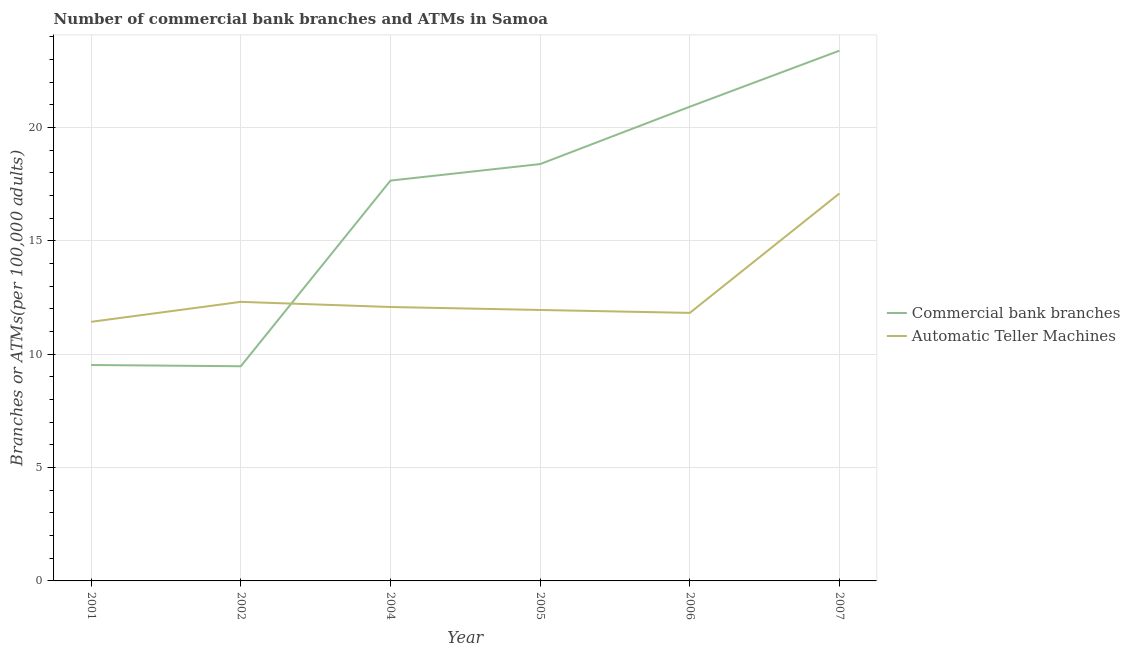How many different coloured lines are there?
Your answer should be very brief. 2. Does the line corresponding to number of atms intersect with the line corresponding to number of commercal bank branches?
Your answer should be compact. Yes. What is the number of atms in 2001?
Give a very brief answer. 11.43. Across all years, what is the maximum number of commercal bank branches?
Provide a succinct answer. 23.4. Across all years, what is the minimum number of commercal bank branches?
Offer a terse response. 9.47. In which year was the number of commercal bank branches maximum?
Ensure brevity in your answer.  2007. What is the total number of atms in the graph?
Make the answer very short. 76.71. What is the difference between the number of atms in 2001 and that in 2004?
Provide a short and direct response. -0.65. What is the difference between the number of atms in 2006 and the number of commercal bank branches in 2001?
Your answer should be very brief. 2.3. What is the average number of atms per year?
Ensure brevity in your answer.  12.79. In the year 2001, what is the difference between the number of commercal bank branches and number of atms?
Your response must be concise. -1.91. In how many years, is the number of commercal bank branches greater than 8?
Your answer should be compact. 6. What is the ratio of the number of atms in 2005 to that in 2006?
Ensure brevity in your answer.  1.01. Is the difference between the number of atms in 2002 and 2005 greater than the difference between the number of commercal bank branches in 2002 and 2005?
Offer a terse response. Yes. What is the difference between the highest and the second highest number of atms?
Provide a succinct answer. 4.78. What is the difference between the highest and the lowest number of atms?
Your answer should be compact. 5.67. In how many years, is the number of commercal bank branches greater than the average number of commercal bank branches taken over all years?
Your answer should be compact. 4. Where does the legend appear in the graph?
Offer a very short reply. Center right. What is the title of the graph?
Ensure brevity in your answer.  Number of commercial bank branches and ATMs in Samoa. What is the label or title of the Y-axis?
Your answer should be compact. Branches or ATMs(per 100,0 adults). What is the Branches or ATMs(per 100,000 adults) of Commercial bank branches in 2001?
Provide a short and direct response. 9.53. What is the Branches or ATMs(per 100,000 adults) of Automatic Teller Machines in 2001?
Offer a terse response. 11.43. What is the Branches or ATMs(per 100,000 adults) of Commercial bank branches in 2002?
Keep it short and to the point. 9.47. What is the Branches or ATMs(per 100,000 adults) of Automatic Teller Machines in 2002?
Your answer should be very brief. 12.31. What is the Branches or ATMs(per 100,000 adults) in Commercial bank branches in 2004?
Offer a terse response. 17.66. What is the Branches or ATMs(per 100,000 adults) of Automatic Teller Machines in 2004?
Provide a short and direct response. 12.09. What is the Branches or ATMs(per 100,000 adults) of Commercial bank branches in 2005?
Provide a short and direct response. 18.39. What is the Branches or ATMs(per 100,000 adults) in Automatic Teller Machines in 2005?
Your answer should be compact. 11.96. What is the Branches or ATMs(per 100,000 adults) of Commercial bank branches in 2006?
Provide a succinct answer. 20.92. What is the Branches or ATMs(per 100,000 adults) of Automatic Teller Machines in 2006?
Make the answer very short. 11.83. What is the Branches or ATMs(per 100,000 adults) in Commercial bank branches in 2007?
Keep it short and to the point. 23.4. What is the Branches or ATMs(per 100,000 adults) in Automatic Teller Machines in 2007?
Ensure brevity in your answer.  17.1. Across all years, what is the maximum Branches or ATMs(per 100,000 adults) in Commercial bank branches?
Keep it short and to the point. 23.4. Across all years, what is the maximum Branches or ATMs(per 100,000 adults) in Automatic Teller Machines?
Your response must be concise. 17.1. Across all years, what is the minimum Branches or ATMs(per 100,000 adults) of Commercial bank branches?
Ensure brevity in your answer.  9.47. Across all years, what is the minimum Branches or ATMs(per 100,000 adults) in Automatic Teller Machines?
Offer a very short reply. 11.43. What is the total Branches or ATMs(per 100,000 adults) in Commercial bank branches in the graph?
Provide a succinct answer. 99.38. What is the total Branches or ATMs(per 100,000 adults) in Automatic Teller Machines in the graph?
Offer a terse response. 76.71. What is the difference between the Branches or ATMs(per 100,000 adults) of Commercial bank branches in 2001 and that in 2002?
Give a very brief answer. 0.06. What is the difference between the Branches or ATMs(per 100,000 adults) of Automatic Teller Machines in 2001 and that in 2002?
Provide a succinct answer. -0.88. What is the difference between the Branches or ATMs(per 100,000 adults) in Commercial bank branches in 2001 and that in 2004?
Keep it short and to the point. -8.14. What is the difference between the Branches or ATMs(per 100,000 adults) of Automatic Teller Machines in 2001 and that in 2004?
Ensure brevity in your answer.  -0.65. What is the difference between the Branches or ATMs(per 100,000 adults) of Commercial bank branches in 2001 and that in 2005?
Keep it short and to the point. -8.87. What is the difference between the Branches or ATMs(per 100,000 adults) of Automatic Teller Machines in 2001 and that in 2005?
Your response must be concise. -0.52. What is the difference between the Branches or ATMs(per 100,000 adults) of Commercial bank branches in 2001 and that in 2006?
Offer a very short reply. -11.4. What is the difference between the Branches or ATMs(per 100,000 adults) of Automatic Teller Machines in 2001 and that in 2006?
Your answer should be very brief. -0.39. What is the difference between the Branches or ATMs(per 100,000 adults) of Commercial bank branches in 2001 and that in 2007?
Provide a short and direct response. -13.87. What is the difference between the Branches or ATMs(per 100,000 adults) in Automatic Teller Machines in 2001 and that in 2007?
Give a very brief answer. -5.67. What is the difference between the Branches or ATMs(per 100,000 adults) of Commercial bank branches in 2002 and that in 2004?
Your answer should be compact. -8.19. What is the difference between the Branches or ATMs(per 100,000 adults) of Automatic Teller Machines in 2002 and that in 2004?
Ensure brevity in your answer.  0.23. What is the difference between the Branches or ATMs(per 100,000 adults) in Commercial bank branches in 2002 and that in 2005?
Your answer should be very brief. -8.92. What is the difference between the Branches or ATMs(per 100,000 adults) in Automatic Teller Machines in 2002 and that in 2005?
Offer a terse response. 0.36. What is the difference between the Branches or ATMs(per 100,000 adults) in Commercial bank branches in 2002 and that in 2006?
Your answer should be very brief. -11.45. What is the difference between the Branches or ATMs(per 100,000 adults) in Automatic Teller Machines in 2002 and that in 2006?
Give a very brief answer. 0.49. What is the difference between the Branches or ATMs(per 100,000 adults) in Commercial bank branches in 2002 and that in 2007?
Your response must be concise. -13.93. What is the difference between the Branches or ATMs(per 100,000 adults) in Automatic Teller Machines in 2002 and that in 2007?
Keep it short and to the point. -4.78. What is the difference between the Branches or ATMs(per 100,000 adults) in Commercial bank branches in 2004 and that in 2005?
Make the answer very short. -0.73. What is the difference between the Branches or ATMs(per 100,000 adults) in Automatic Teller Machines in 2004 and that in 2005?
Your answer should be compact. 0.13. What is the difference between the Branches or ATMs(per 100,000 adults) in Commercial bank branches in 2004 and that in 2006?
Give a very brief answer. -3.26. What is the difference between the Branches or ATMs(per 100,000 adults) in Automatic Teller Machines in 2004 and that in 2006?
Provide a short and direct response. 0.26. What is the difference between the Branches or ATMs(per 100,000 adults) of Commercial bank branches in 2004 and that in 2007?
Make the answer very short. -5.73. What is the difference between the Branches or ATMs(per 100,000 adults) in Automatic Teller Machines in 2004 and that in 2007?
Offer a very short reply. -5.01. What is the difference between the Branches or ATMs(per 100,000 adults) in Commercial bank branches in 2005 and that in 2006?
Offer a terse response. -2.53. What is the difference between the Branches or ATMs(per 100,000 adults) in Automatic Teller Machines in 2005 and that in 2006?
Provide a succinct answer. 0.13. What is the difference between the Branches or ATMs(per 100,000 adults) in Commercial bank branches in 2005 and that in 2007?
Make the answer very short. -5. What is the difference between the Branches or ATMs(per 100,000 adults) of Automatic Teller Machines in 2005 and that in 2007?
Your answer should be compact. -5.14. What is the difference between the Branches or ATMs(per 100,000 adults) of Commercial bank branches in 2006 and that in 2007?
Offer a very short reply. -2.47. What is the difference between the Branches or ATMs(per 100,000 adults) of Automatic Teller Machines in 2006 and that in 2007?
Ensure brevity in your answer.  -5.27. What is the difference between the Branches or ATMs(per 100,000 adults) in Commercial bank branches in 2001 and the Branches or ATMs(per 100,000 adults) in Automatic Teller Machines in 2002?
Your response must be concise. -2.79. What is the difference between the Branches or ATMs(per 100,000 adults) of Commercial bank branches in 2001 and the Branches or ATMs(per 100,000 adults) of Automatic Teller Machines in 2004?
Give a very brief answer. -2.56. What is the difference between the Branches or ATMs(per 100,000 adults) of Commercial bank branches in 2001 and the Branches or ATMs(per 100,000 adults) of Automatic Teller Machines in 2005?
Make the answer very short. -2.43. What is the difference between the Branches or ATMs(per 100,000 adults) in Commercial bank branches in 2001 and the Branches or ATMs(per 100,000 adults) in Automatic Teller Machines in 2006?
Your answer should be very brief. -2.3. What is the difference between the Branches or ATMs(per 100,000 adults) in Commercial bank branches in 2001 and the Branches or ATMs(per 100,000 adults) in Automatic Teller Machines in 2007?
Ensure brevity in your answer.  -7.57. What is the difference between the Branches or ATMs(per 100,000 adults) of Commercial bank branches in 2002 and the Branches or ATMs(per 100,000 adults) of Automatic Teller Machines in 2004?
Provide a short and direct response. -2.61. What is the difference between the Branches or ATMs(per 100,000 adults) in Commercial bank branches in 2002 and the Branches or ATMs(per 100,000 adults) in Automatic Teller Machines in 2005?
Offer a very short reply. -2.48. What is the difference between the Branches or ATMs(per 100,000 adults) of Commercial bank branches in 2002 and the Branches or ATMs(per 100,000 adults) of Automatic Teller Machines in 2006?
Give a very brief answer. -2.35. What is the difference between the Branches or ATMs(per 100,000 adults) in Commercial bank branches in 2002 and the Branches or ATMs(per 100,000 adults) in Automatic Teller Machines in 2007?
Ensure brevity in your answer.  -7.63. What is the difference between the Branches or ATMs(per 100,000 adults) of Commercial bank branches in 2004 and the Branches or ATMs(per 100,000 adults) of Automatic Teller Machines in 2005?
Your answer should be very brief. 5.71. What is the difference between the Branches or ATMs(per 100,000 adults) of Commercial bank branches in 2004 and the Branches or ATMs(per 100,000 adults) of Automatic Teller Machines in 2006?
Your response must be concise. 5.84. What is the difference between the Branches or ATMs(per 100,000 adults) in Commercial bank branches in 2004 and the Branches or ATMs(per 100,000 adults) in Automatic Teller Machines in 2007?
Your answer should be very brief. 0.57. What is the difference between the Branches or ATMs(per 100,000 adults) of Commercial bank branches in 2005 and the Branches or ATMs(per 100,000 adults) of Automatic Teller Machines in 2006?
Keep it short and to the point. 6.57. What is the difference between the Branches or ATMs(per 100,000 adults) in Commercial bank branches in 2005 and the Branches or ATMs(per 100,000 adults) in Automatic Teller Machines in 2007?
Your response must be concise. 1.29. What is the difference between the Branches or ATMs(per 100,000 adults) of Commercial bank branches in 2006 and the Branches or ATMs(per 100,000 adults) of Automatic Teller Machines in 2007?
Give a very brief answer. 3.83. What is the average Branches or ATMs(per 100,000 adults) of Commercial bank branches per year?
Give a very brief answer. 16.56. What is the average Branches or ATMs(per 100,000 adults) of Automatic Teller Machines per year?
Keep it short and to the point. 12.79. In the year 2001, what is the difference between the Branches or ATMs(per 100,000 adults) in Commercial bank branches and Branches or ATMs(per 100,000 adults) in Automatic Teller Machines?
Offer a very short reply. -1.91. In the year 2002, what is the difference between the Branches or ATMs(per 100,000 adults) in Commercial bank branches and Branches or ATMs(per 100,000 adults) in Automatic Teller Machines?
Provide a succinct answer. -2.84. In the year 2004, what is the difference between the Branches or ATMs(per 100,000 adults) in Commercial bank branches and Branches or ATMs(per 100,000 adults) in Automatic Teller Machines?
Your response must be concise. 5.58. In the year 2005, what is the difference between the Branches or ATMs(per 100,000 adults) in Commercial bank branches and Branches or ATMs(per 100,000 adults) in Automatic Teller Machines?
Make the answer very short. 6.44. In the year 2006, what is the difference between the Branches or ATMs(per 100,000 adults) in Commercial bank branches and Branches or ATMs(per 100,000 adults) in Automatic Teller Machines?
Keep it short and to the point. 9.1. In the year 2007, what is the difference between the Branches or ATMs(per 100,000 adults) of Commercial bank branches and Branches or ATMs(per 100,000 adults) of Automatic Teller Machines?
Your answer should be compact. 6.3. What is the ratio of the Branches or ATMs(per 100,000 adults) of Automatic Teller Machines in 2001 to that in 2002?
Provide a short and direct response. 0.93. What is the ratio of the Branches or ATMs(per 100,000 adults) of Commercial bank branches in 2001 to that in 2004?
Provide a short and direct response. 0.54. What is the ratio of the Branches or ATMs(per 100,000 adults) of Automatic Teller Machines in 2001 to that in 2004?
Your answer should be compact. 0.95. What is the ratio of the Branches or ATMs(per 100,000 adults) in Commercial bank branches in 2001 to that in 2005?
Give a very brief answer. 0.52. What is the ratio of the Branches or ATMs(per 100,000 adults) of Automatic Teller Machines in 2001 to that in 2005?
Keep it short and to the point. 0.96. What is the ratio of the Branches or ATMs(per 100,000 adults) of Commercial bank branches in 2001 to that in 2006?
Your answer should be very brief. 0.46. What is the ratio of the Branches or ATMs(per 100,000 adults) in Automatic Teller Machines in 2001 to that in 2006?
Ensure brevity in your answer.  0.97. What is the ratio of the Branches or ATMs(per 100,000 adults) in Commercial bank branches in 2001 to that in 2007?
Make the answer very short. 0.41. What is the ratio of the Branches or ATMs(per 100,000 adults) in Automatic Teller Machines in 2001 to that in 2007?
Ensure brevity in your answer.  0.67. What is the ratio of the Branches or ATMs(per 100,000 adults) in Commercial bank branches in 2002 to that in 2004?
Offer a terse response. 0.54. What is the ratio of the Branches or ATMs(per 100,000 adults) of Automatic Teller Machines in 2002 to that in 2004?
Your answer should be compact. 1.02. What is the ratio of the Branches or ATMs(per 100,000 adults) of Commercial bank branches in 2002 to that in 2005?
Give a very brief answer. 0.52. What is the ratio of the Branches or ATMs(per 100,000 adults) in Automatic Teller Machines in 2002 to that in 2005?
Your answer should be compact. 1.03. What is the ratio of the Branches or ATMs(per 100,000 adults) of Commercial bank branches in 2002 to that in 2006?
Ensure brevity in your answer.  0.45. What is the ratio of the Branches or ATMs(per 100,000 adults) in Automatic Teller Machines in 2002 to that in 2006?
Provide a succinct answer. 1.04. What is the ratio of the Branches or ATMs(per 100,000 adults) in Commercial bank branches in 2002 to that in 2007?
Provide a short and direct response. 0.4. What is the ratio of the Branches or ATMs(per 100,000 adults) of Automatic Teller Machines in 2002 to that in 2007?
Your answer should be very brief. 0.72. What is the ratio of the Branches or ATMs(per 100,000 adults) of Commercial bank branches in 2004 to that in 2005?
Provide a succinct answer. 0.96. What is the ratio of the Branches or ATMs(per 100,000 adults) of Automatic Teller Machines in 2004 to that in 2005?
Your answer should be compact. 1.01. What is the ratio of the Branches or ATMs(per 100,000 adults) of Commercial bank branches in 2004 to that in 2006?
Your response must be concise. 0.84. What is the ratio of the Branches or ATMs(per 100,000 adults) in Automatic Teller Machines in 2004 to that in 2006?
Provide a short and direct response. 1.02. What is the ratio of the Branches or ATMs(per 100,000 adults) in Commercial bank branches in 2004 to that in 2007?
Your response must be concise. 0.76. What is the ratio of the Branches or ATMs(per 100,000 adults) in Automatic Teller Machines in 2004 to that in 2007?
Offer a very short reply. 0.71. What is the ratio of the Branches or ATMs(per 100,000 adults) in Commercial bank branches in 2005 to that in 2006?
Ensure brevity in your answer.  0.88. What is the ratio of the Branches or ATMs(per 100,000 adults) in Automatic Teller Machines in 2005 to that in 2006?
Make the answer very short. 1.01. What is the ratio of the Branches or ATMs(per 100,000 adults) of Commercial bank branches in 2005 to that in 2007?
Give a very brief answer. 0.79. What is the ratio of the Branches or ATMs(per 100,000 adults) in Automatic Teller Machines in 2005 to that in 2007?
Make the answer very short. 0.7. What is the ratio of the Branches or ATMs(per 100,000 adults) in Commercial bank branches in 2006 to that in 2007?
Offer a terse response. 0.89. What is the ratio of the Branches or ATMs(per 100,000 adults) in Automatic Teller Machines in 2006 to that in 2007?
Offer a very short reply. 0.69. What is the difference between the highest and the second highest Branches or ATMs(per 100,000 adults) in Commercial bank branches?
Provide a short and direct response. 2.47. What is the difference between the highest and the second highest Branches or ATMs(per 100,000 adults) in Automatic Teller Machines?
Provide a short and direct response. 4.78. What is the difference between the highest and the lowest Branches or ATMs(per 100,000 adults) in Commercial bank branches?
Give a very brief answer. 13.93. What is the difference between the highest and the lowest Branches or ATMs(per 100,000 adults) in Automatic Teller Machines?
Your answer should be compact. 5.67. 